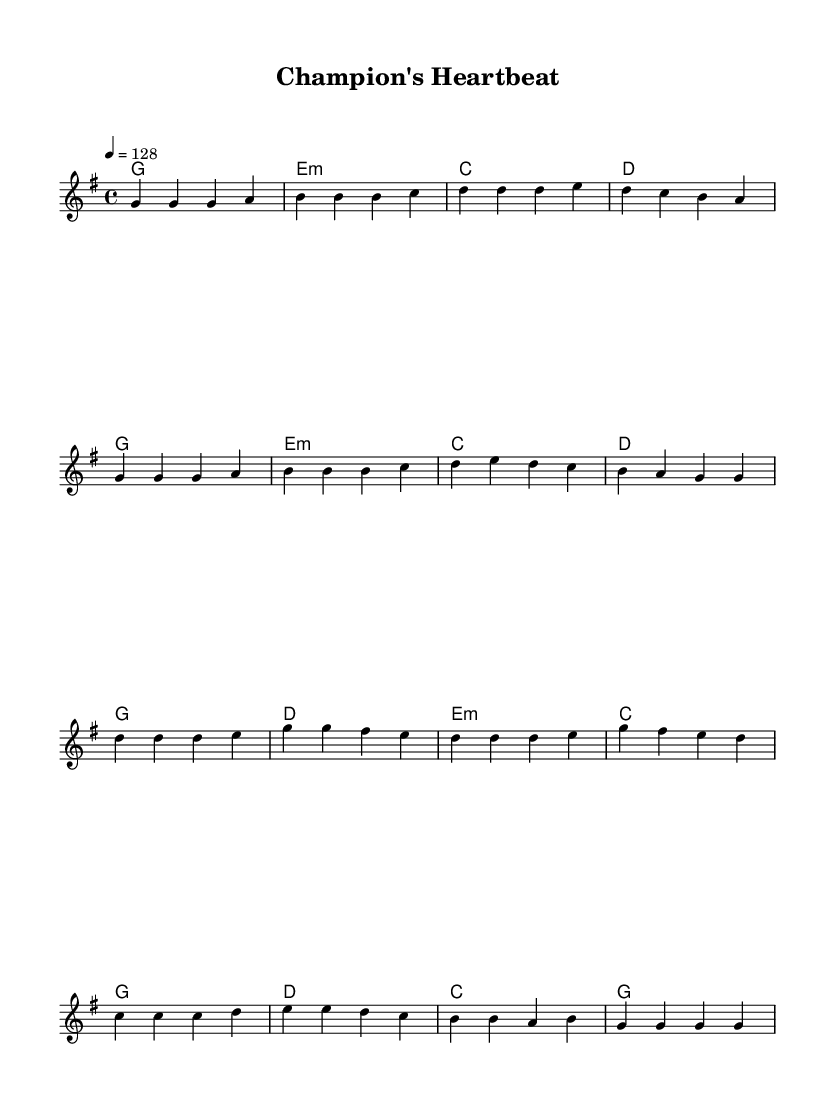What is the key signature of this music? The key signature is G major, which has one sharp (F#). This can be identified by looking at the key signature indicator at the beginning of the staff, which shows a single sharp.
Answer: G major What is the time signature of this piece? The time signature is 4/4, which indicates that there are four beats in each measure and the quarter note receives one beat. This is usually located at the beginning of the staff next to the key signature.
Answer: 4/4 What is the tempo marking of the music? The tempo marking is "128," which indicates the beats per minute (BPM). This is specified in the tempo indication at the start of the score and reflects a moderately fast pace suitable for dance music.
Answer: 128 How many measures are there in the verse section? The verse section consists of 8 measures. To determine this, you can count each distinct grouping of notes separated by the bar lines in the melody section.
Answer: 8 In which section does the melody feature the notes d and g together? The notes d and g appear in the chorus section. You can identify this by looking for the measures that contain these notes simultaneously, which are specifically part of the chorus melody line.
Answer: Chorus What is the first chord used in the piece? The first chord used is G major. This can be observed at the start of the chord section, where the chord is indicated above the melody and is reiterated in the first measure of the harmony.
Answer: G major How many different chords are used in the chorus? The chorus uses three different chords: G major, D major, and E minor. You can determine this by referencing the chord progression throughout the chorus section of the score.
Answer: 3 